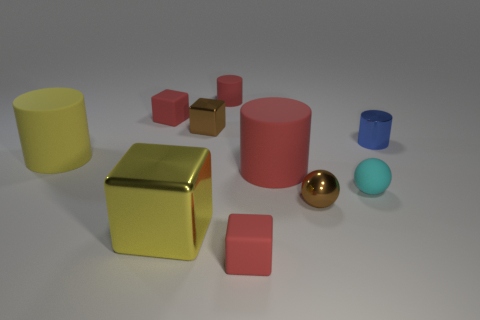Subtract all tiny red cylinders. How many cylinders are left? 3 Subtract 1 spheres. How many spheres are left? 1 Subtract all brown balls. How many balls are left? 1 Subtract all blue cubes. How many cyan cylinders are left? 0 Subtract all cubes. How many objects are left? 6 Subtract all green blocks. Subtract all green balls. How many blocks are left? 4 Subtract all tiny green cylinders. Subtract all red matte cylinders. How many objects are left? 8 Add 5 metallic spheres. How many metallic spheres are left? 6 Add 1 tiny brown balls. How many tiny brown balls exist? 2 Subtract 0 purple cylinders. How many objects are left? 10 